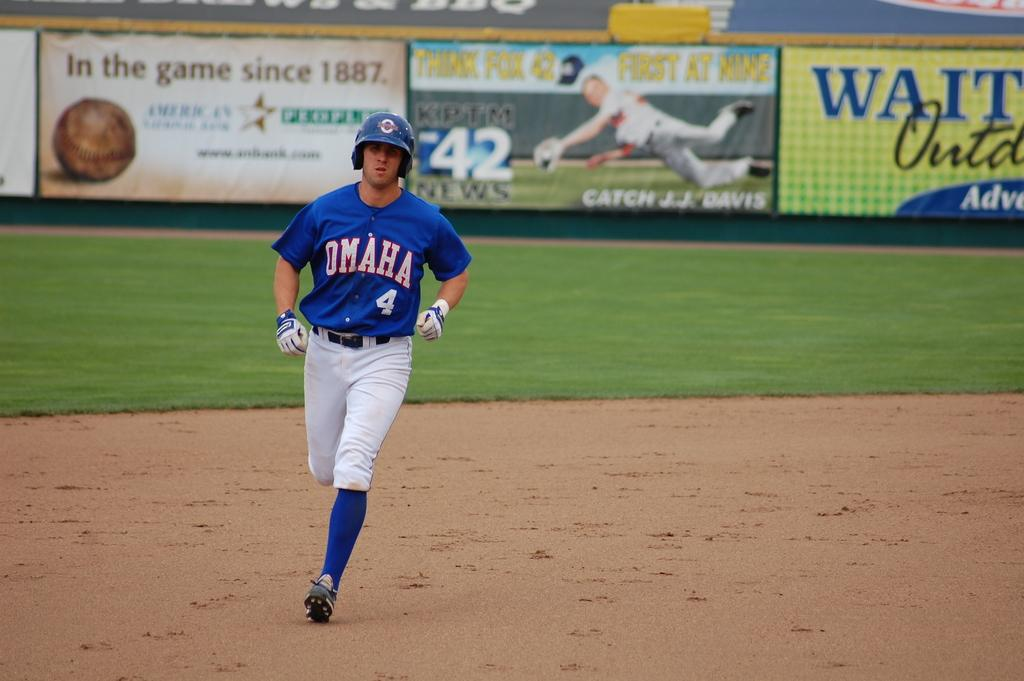<image>
Relay a brief, clear account of the picture shown. za person wearing a jrsey that says Omaha 